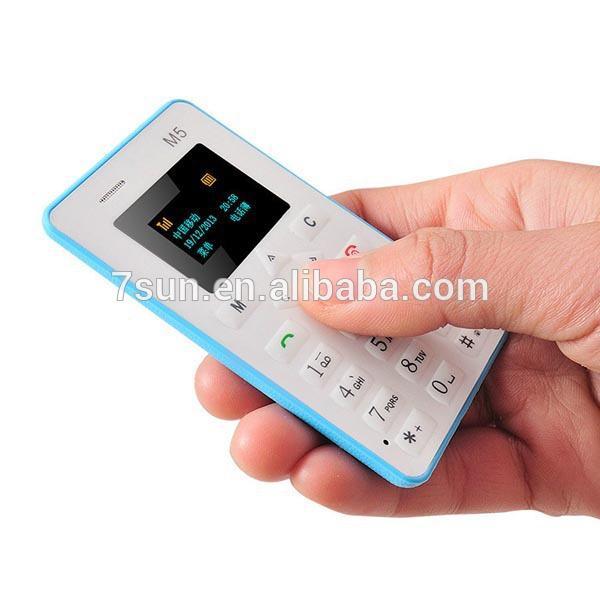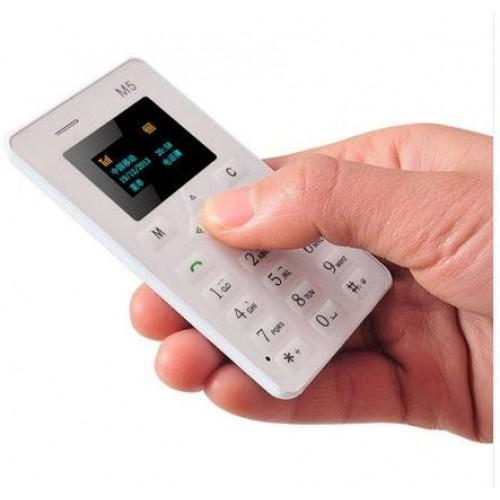The first image is the image on the left, the second image is the image on the right. Given the left and right images, does the statement "A person is holding something in the right image." hold true? Answer yes or no. Yes. The first image is the image on the left, the second image is the image on the right. Analyze the images presented: Is the assertion "A person is holding a white device in the image on the left." valid? Answer yes or no. Yes. 